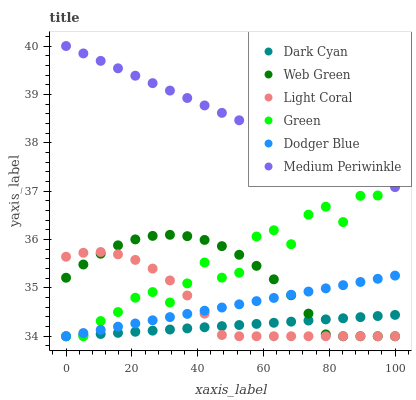Does Dark Cyan have the minimum area under the curve?
Answer yes or no. Yes. Does Medium Periwinkle have the maximum area under the curve?
Answer yes or no. Yes. Does Web Green have the minimum area under the curve?
Answer yes or no. No. Does Web Green have the maximum area under the curve?
Answer yes or no. No. Is Dark Cyan the smoothest?
Answer yes or no. Yes. Is Green the roughest?
Answer yes or no. Yes. Is Web Green the smoothest?
Answer yes or no. No. Is Web Green the roughest?
Answer yes or no. No. Does Web Green have the lowest value?
Answer yes or no. Yes. Does Medium Periwinkle have the highest value?
Answer yes or no. Yes. Does Web Green have the highest value?
Answer yes or no. No. Is Dodger Blue less than Medium Periwinkle?
Answer yes or no. Yes. Is Medium Periwinkle greater than Dark Cyan?
Answer yes or no. Yes. Does Dark Cyan intersect Dodger Blue?
Answer yes or no. Yes. Is Dark Cyan less than Dodger Blue?
Answer yes or no. No. Is Dark Cyan greater than Dodger Blue?
Answer yes or no. No. Does Dodger Blue intersect Medium Periwinkle?
Answer yes or no. No. 